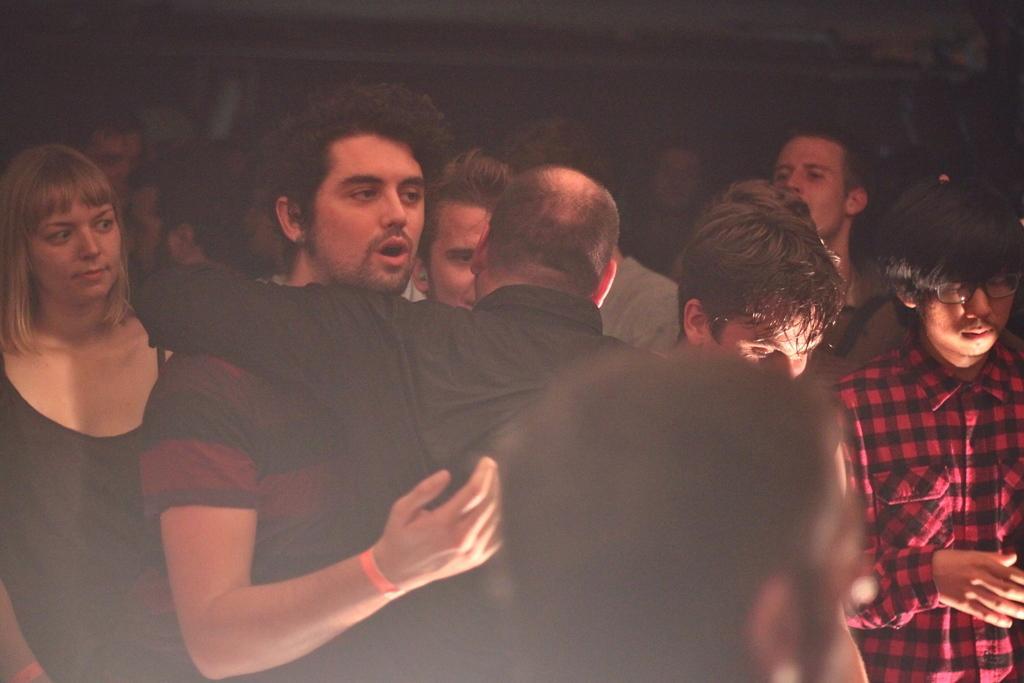Could you give a brief overview of what you see in this image? There are group of people standing. I can see two people hugging each other. The background looks dark. 